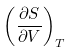Convert formula to latex. <formula><loc_0><loc_0><loc_500><loc_500>\left ( { \frac { \partial S } { \partial V } } \right ) _ { T }</formula> 